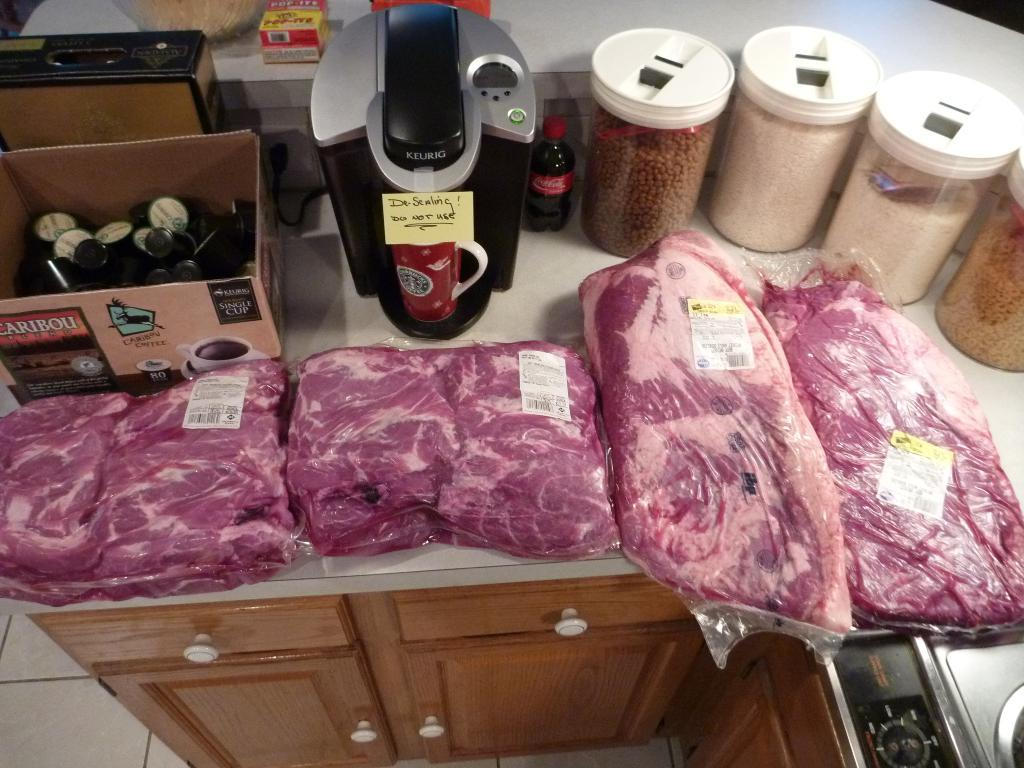<image>
Provide a brief description of the given image. Dr. Sealing does not approve of sharing their coffee mug with anyone. 